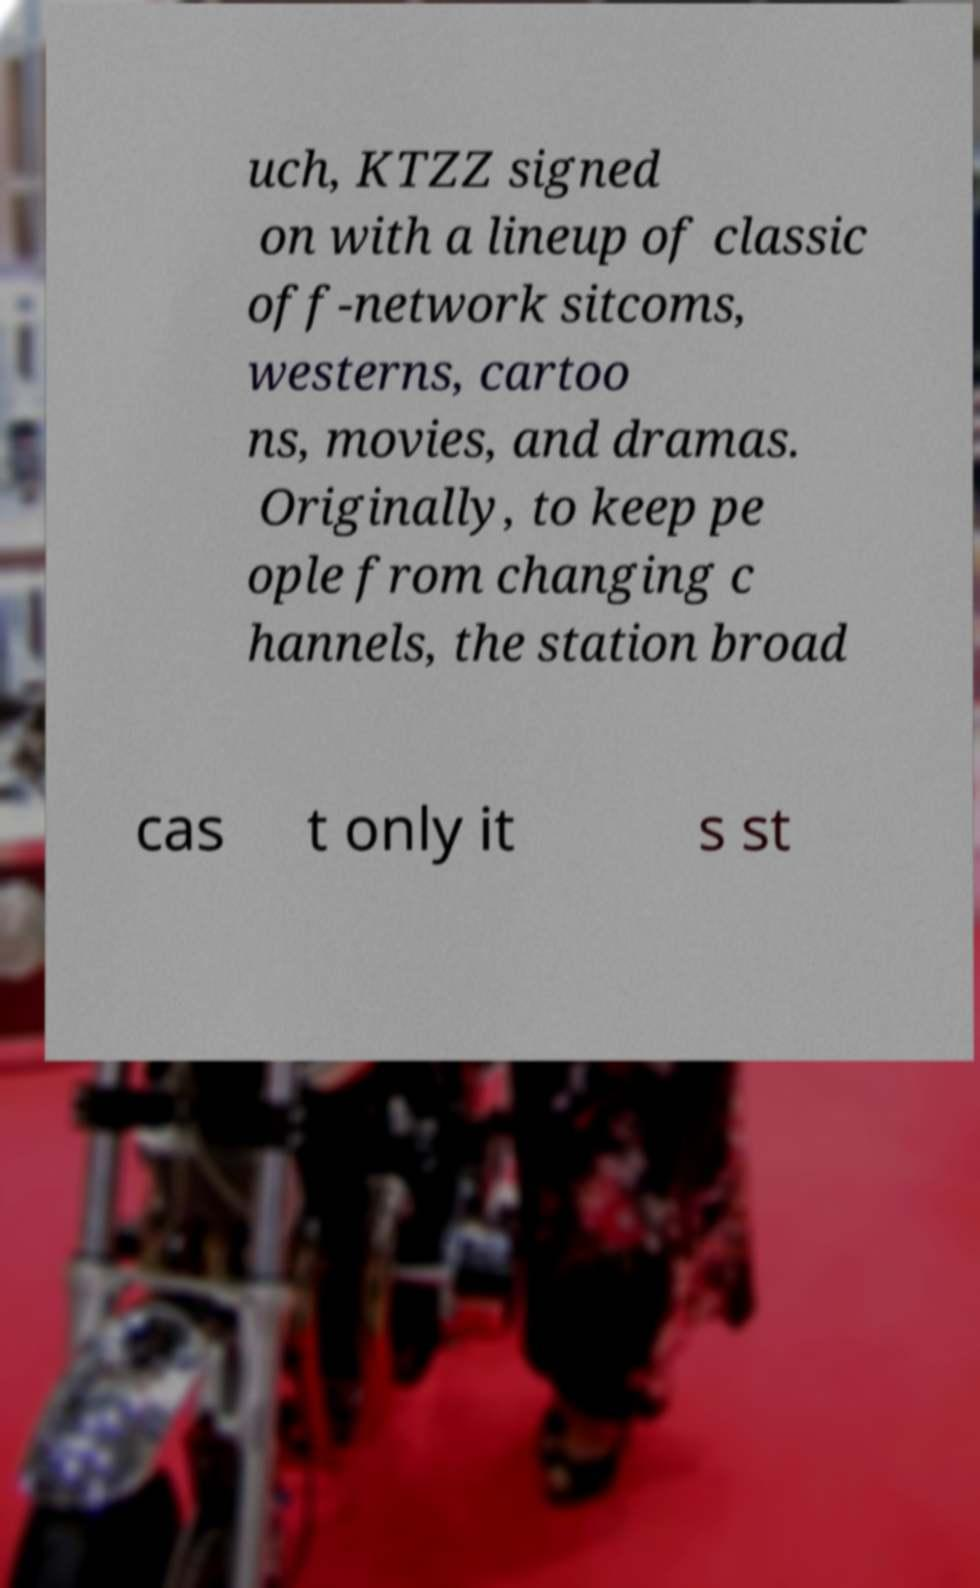I need the written content from this picture converted into text. Can you do that? uch, KTZZ signed on with a lineup of classic off-network sitcoms, westerns, cartoo ns, movies, and dramas. Originally, to keep pe ople from changing c hannels, the station broad cas t only it s st 